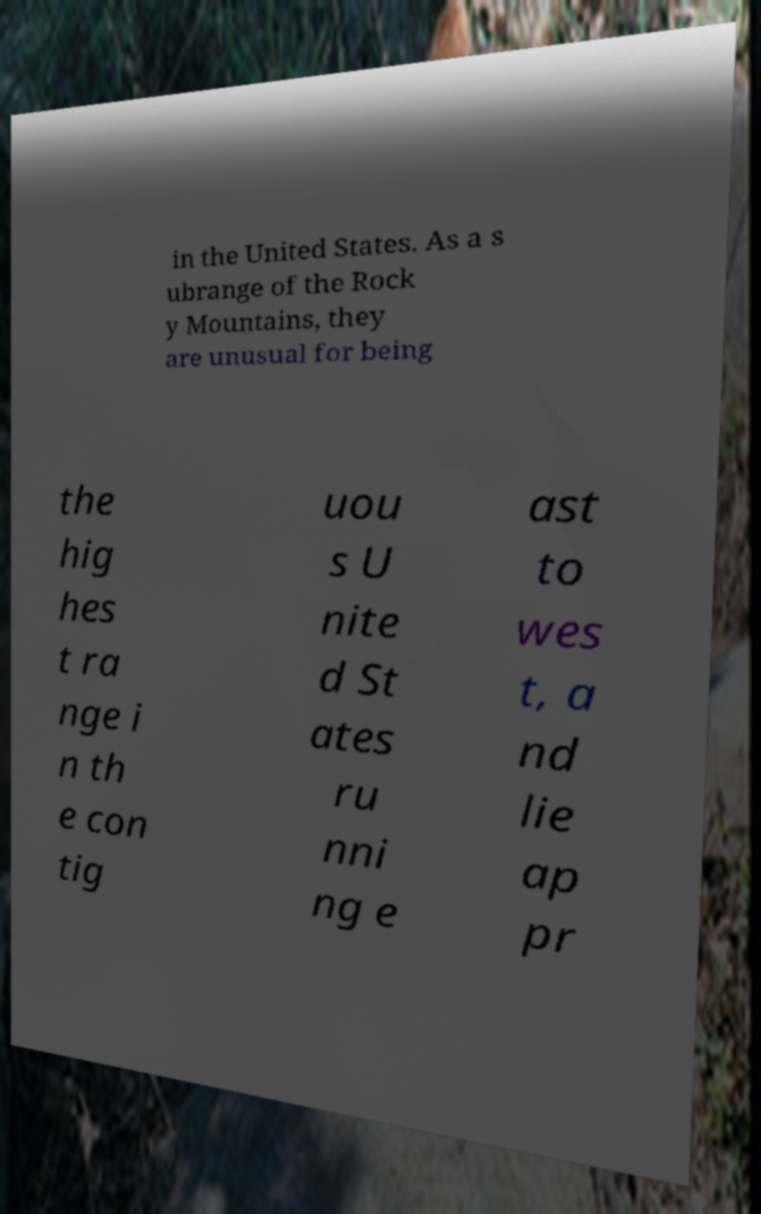I need the written content from this picture converted into text. Can you do that? in the United States. As a s ubrange of the Rock y Mountains, they are unusual for being the hig hes t ra nge i n th e con tig uou s U nite d St ates ru nni ng e ast to wes t, a nd lie ap pr 